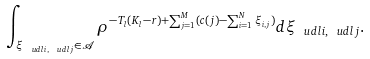<formula> <loc_0><loc_0><loc_500><loc_500>\int _ { \xi _ { \ u d l { i } , \ u d l { j } } \in \mathcal { A } } \rho ^ { - T _ { l } ( K _ { l } - r ) + \sum _ { j = 1 } ^ { M } ( c ( j ) - \sum _ { i = 1 } ^ { N } \xi _ { i , j } ) } d \xi _ { \ u d l { i } , \ u d l { j } } .</formula> 